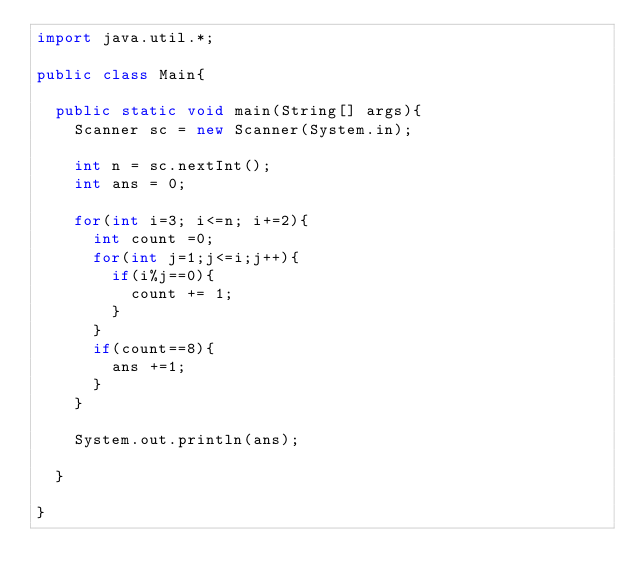Convert code to text. <code><loc_0><loc_0><loc_500><loc_500><_Java_>import java.util.*;

public class Main{

  public static void main(String[] args){
    Scanner sc = new Scanner(System.in);

    int n = sc.nextInt();
    int ans = 0;

    for(int i=3; i<=n; i+=2){
      int count =0;
      for(int j=1;j<=i;j++){
        if(i%j==0){
          count += 1;
        }
      }
      if(count==8){
        ans +=1;
      }
    }

    System.out.println(ans);

  }

}</code> 